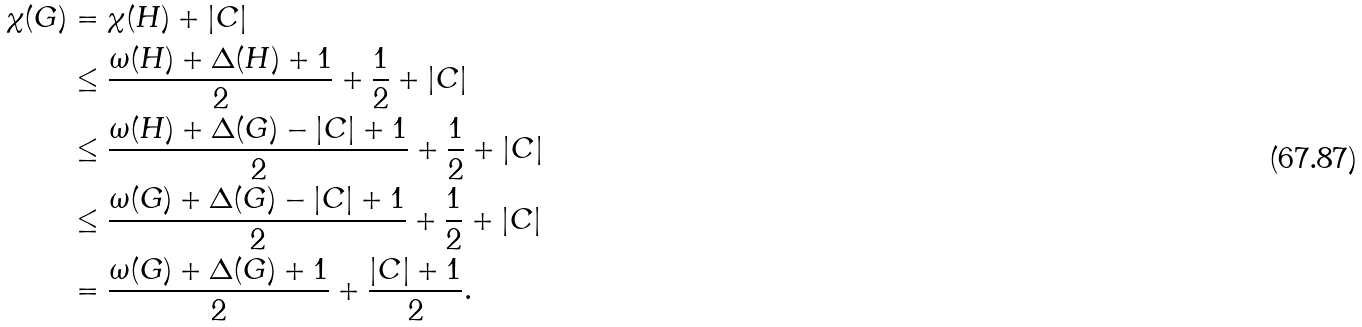<formula> <loc_0><loc_0><loc_500><loc_500>\chi ( G ) & = \chi ( H ) + | C | \\ & \leq \frac { \omega ( H ) + \Delta ( H ) + 1 } { 2 } + \frac { 1 } { 2 } + | C | \\ & \leq \frac { \omega ( H ) + \Delta ( G ) - | C | + 1 } { 2 } + \frac { 1 } { 2 } + | C | \\ & \leq \frac { \omega ( G ) + \Delta ( G ) - | C | + 1 } { 2 } + \frac { 1 } { 2 } + | C | \\ & = \frac { \omega ( G ) + \Delta ( G ) + 1 } { 2 } + \frac { | C | + 1 } { 2 } . \\</formula> 